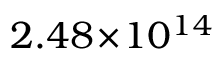Convert formula to latex. <formula><loc_0><loc_0><loc_500><loc_500>2 . 4 8 \, \times \, 1 0 ^ { 1 4 }</formula> 